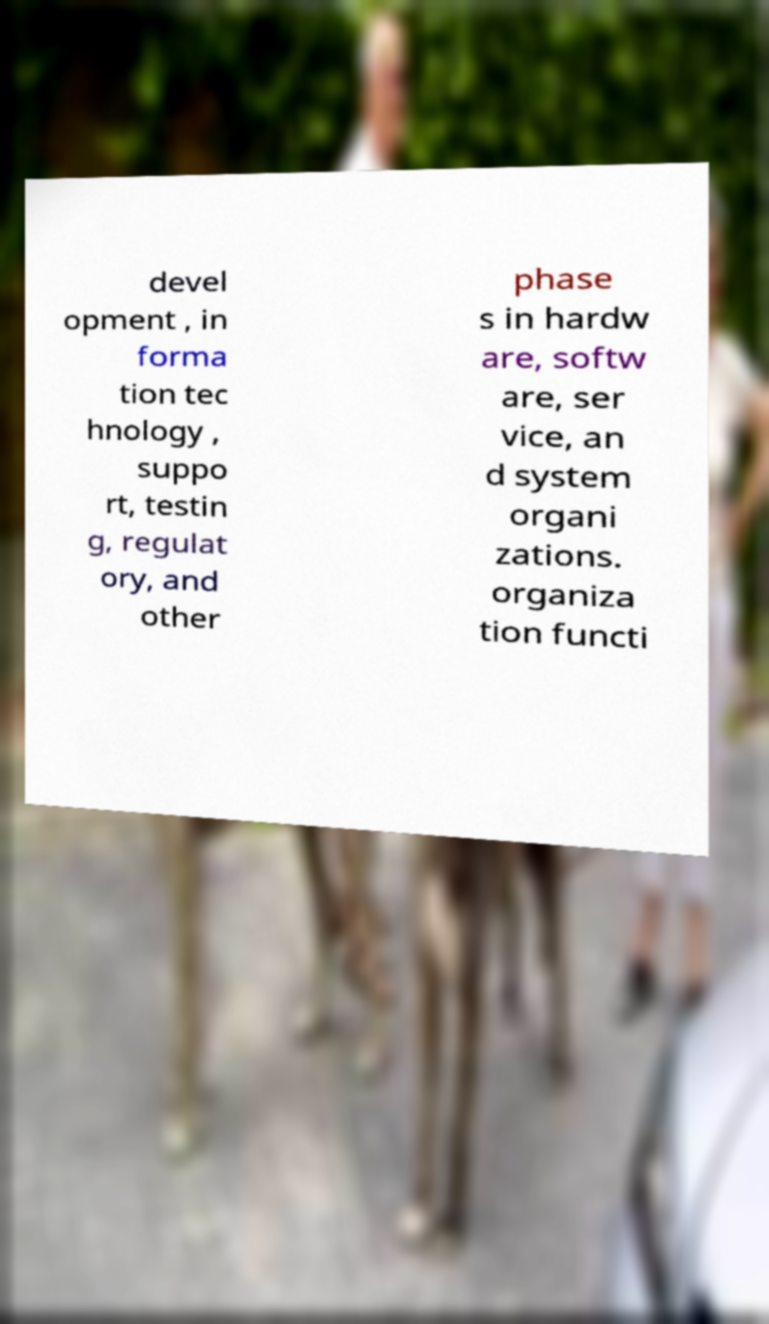What messages or text are displayed in this image? I need them in a readable, typed format. devel opment , in forma tion tec hnology , suppo rt, testin g, regulat ory, and other phase s in hardw are, softw are, ser vice, an d system organi zations. organiza tion functi 